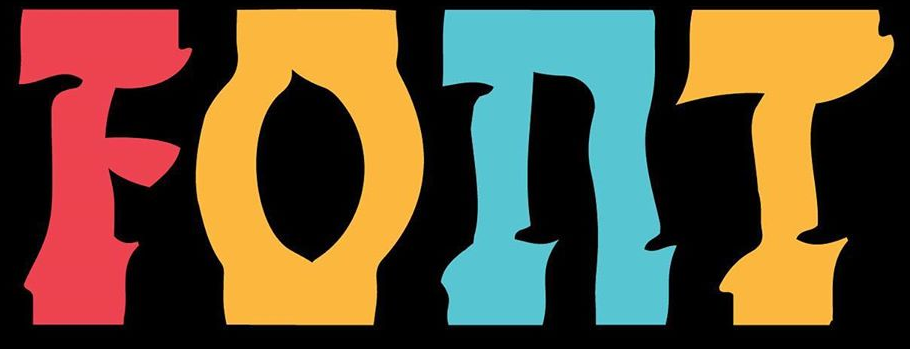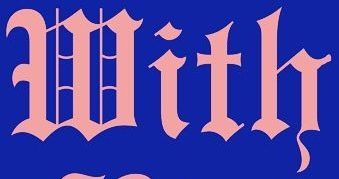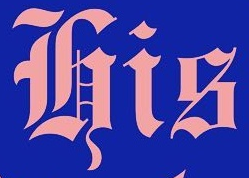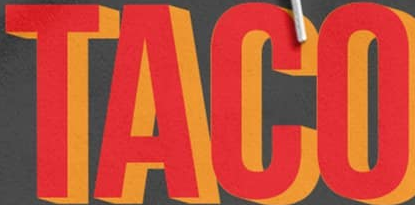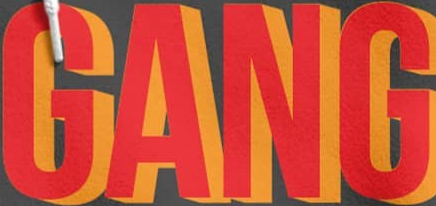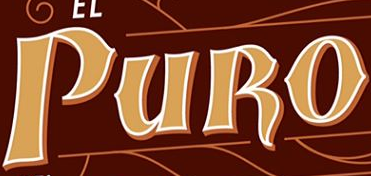What words can you see in these images in sequence, separated by a semicolon? FOnT; With; His; TACO; GANG; PURO 